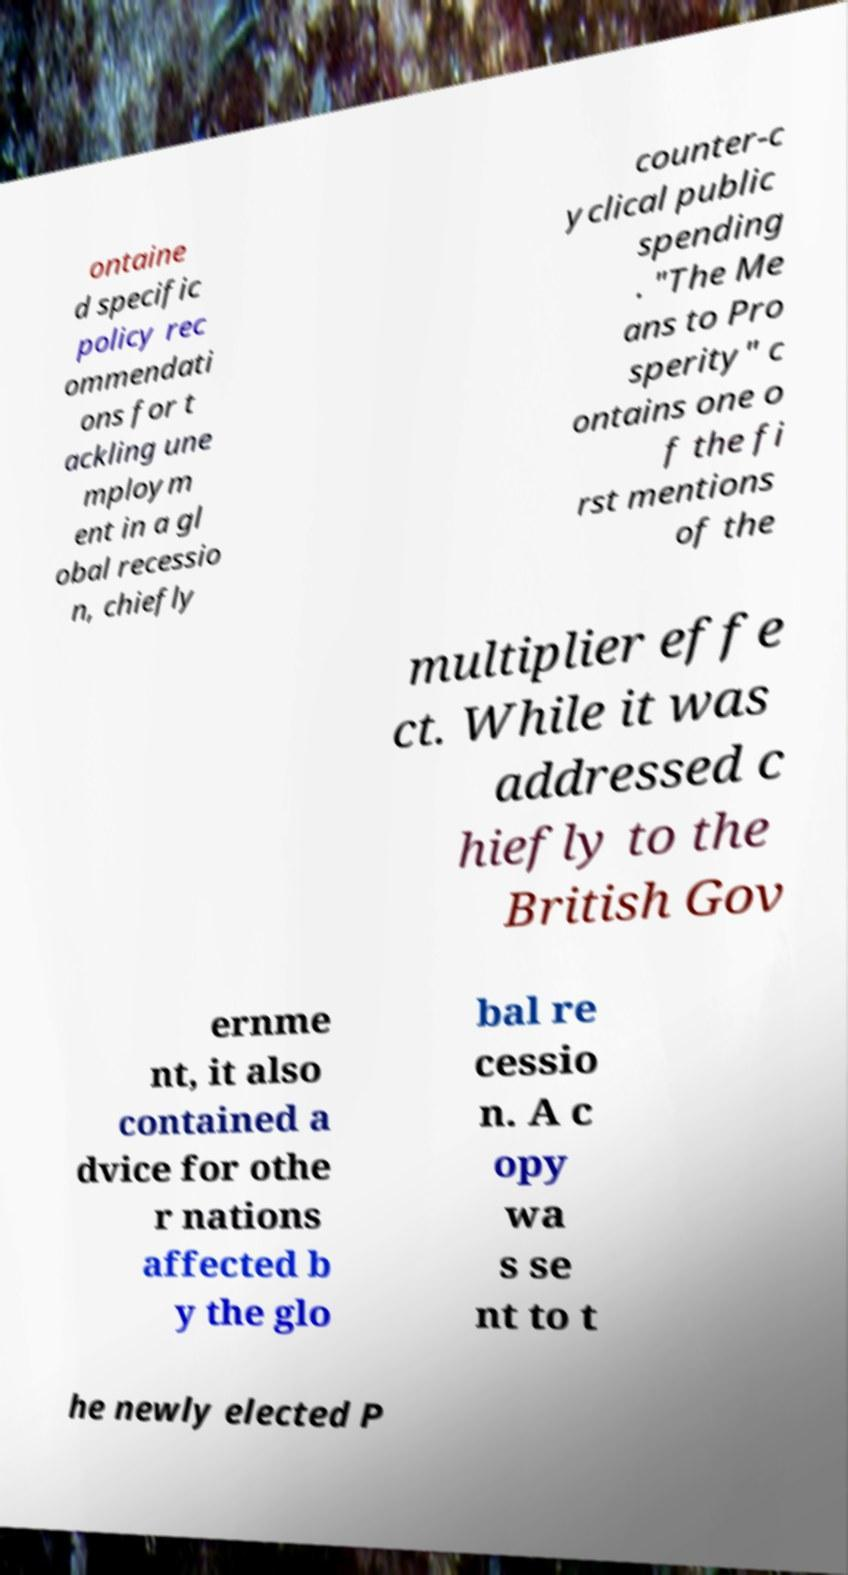Please read and relay the text visible in this image. What does it say? ontaine d specific policy rec ommendati ons for t ackling une mploym ent in a gl obal recessio n, chiefly counter-c yclical public spending . "The Me ans to Pro sperity" c ontains one o f the fi rst mentions of the multiplier effe ct. While it was addressed c hiefly to the British Gov ernme nt, it also contained a dvice for othe r nations affected b y the glo bal re cessio n. A c opy wa s se nt to t he newly elected P 